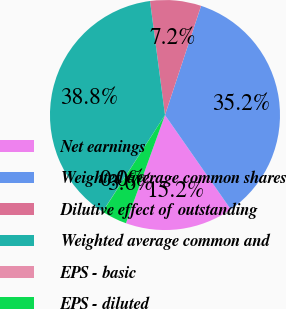Convert chart. <chart><loc_0><loc_0><loc_500><loc_500><pie_chart><fcel>Net earnings<fcel>Weighted average common shares<fcel>Dilutive effect of outstanding<fcel>Weighted average common and<fcel>EPS - basic<fcel>EPS - diluted<nl><fcel>15.2%<fcel>35.23%<fcel>7.16%<fcel>38.8%<fcel>0.02%<fcel>3.59%<nl></chart> 